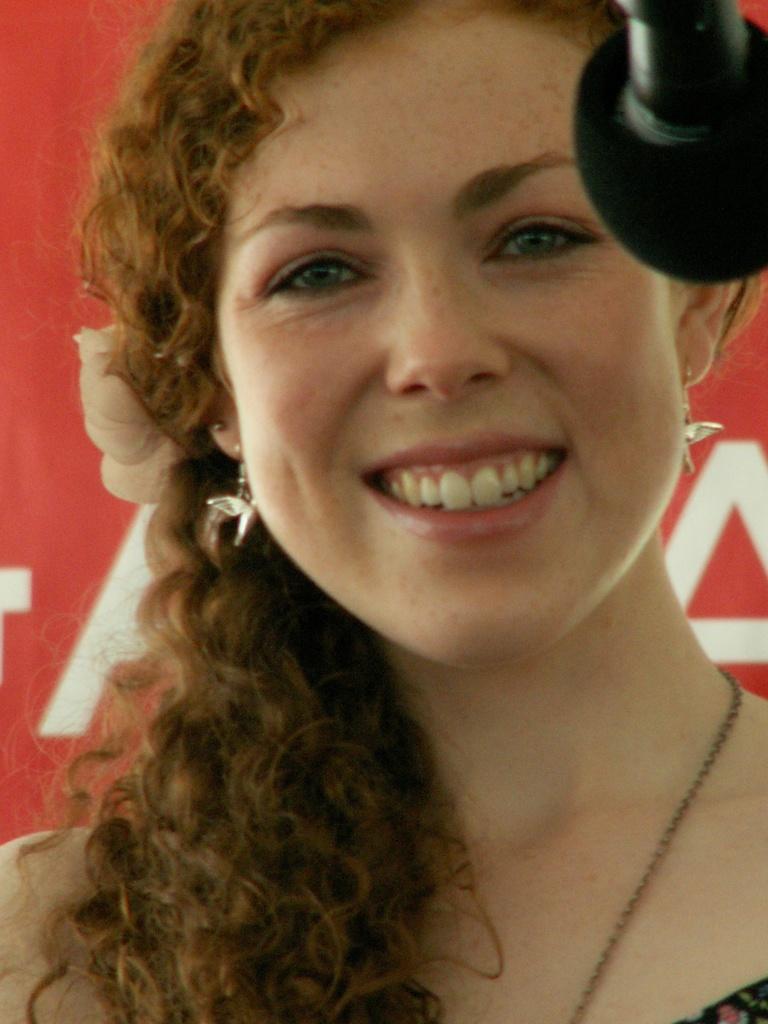How would you summarize this image in a sentence or two? This is a close up of a woman wearing clothes, neck chain, earrings and she is smiling. Here we can see a microphone and a poster. 